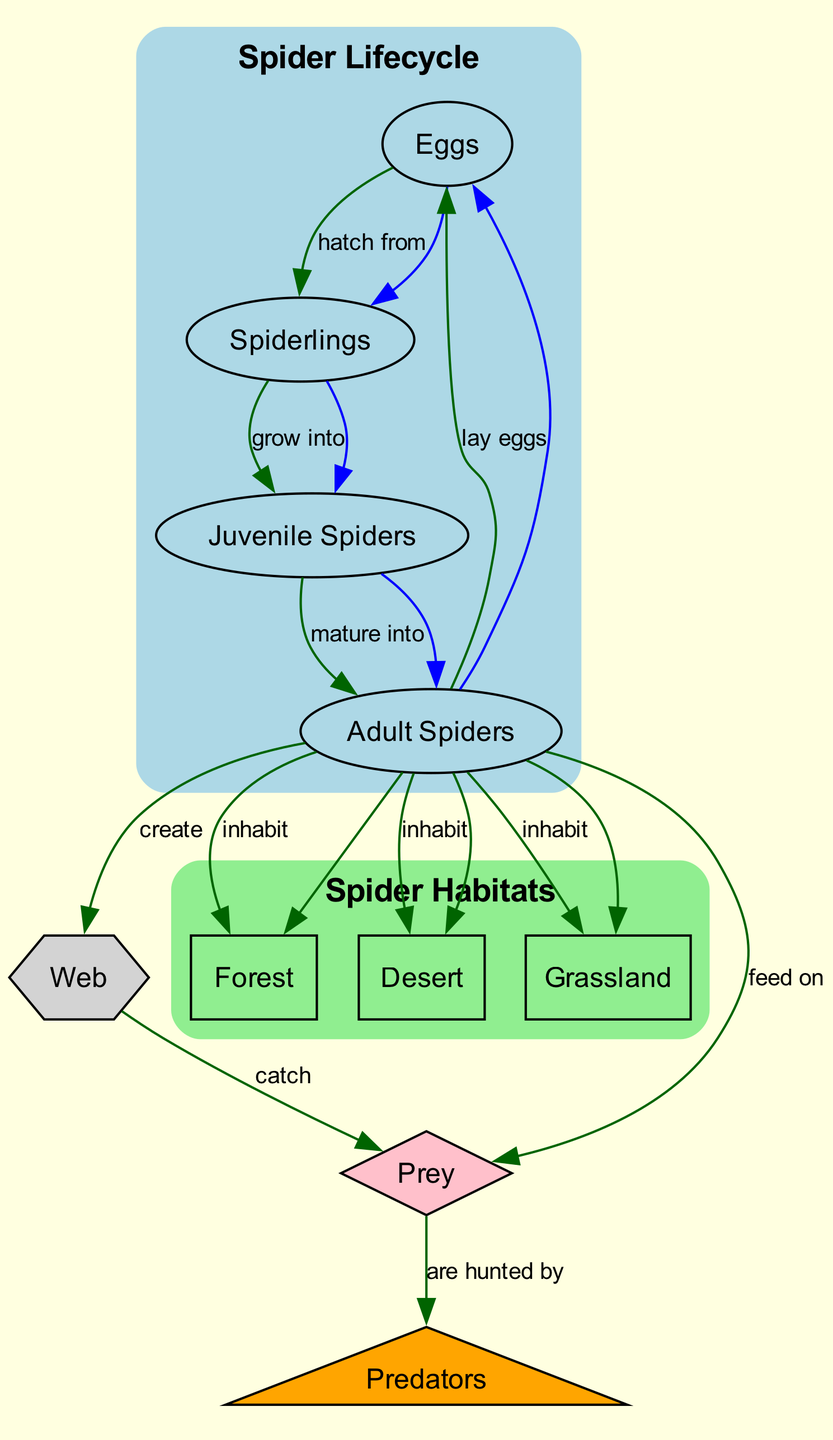What is the first stage in the spider lifecycle? The diagram starts by presenting "Eggs" as the first node in the spider lifecycle. This stage is indicated by the arrows leading from this node to the "Spiderlings" node, highlighting that the lifecycle begins with eggs being laid.
Answer: Eggs How many habitats are there where adult spiders inhabit? The diagram shows three edges leading from the "Adult Spiders" node to the habitat nodes: "Forest," "Desert," and "Grassland." By counting these connections, we find that there are three different habitats.
Answer: 3 What do adult spiders feed on? By following the edge from the "Adult Spiders" node to the "Prey" node, we can see that adult spiders have an arrow pointing to the prey, which indicates that they feed on insects and small animals.
Answer: Prey What stage comes after spiderlings? The flow from "Spiderlings" leads directly to the "Juvenile Spiders" node, indicating the development stage that follows spiderlings. Therefore, the answer is "Juvenile Spiders."
Answer: Juvenile Spiders Which habitat is primarily occupied by specially adapted spiders? The edges from the "Adult Spiders" node include a connection to "Desert," which is labeled as having specially adapted spiders. This information directly tells us which environment hosts these spiders.
Answer: Desert How do adult spiders catch their prey? The arrow from the "Web" node to the "Prey" node indicates that adult spiders create webs specifically to catch their prey. This relationship illustrates the role of webs in hunting.
Answer: Catch What do spiders create to assist in catching prey? The "Adult Spiders" node is linked to the "Web" node with an edge stating "create," indicating that adult spiders build webs as part of their hunting strategy.
Answer: Web Who hunts the prey of adult spiders? The diagram illustrates a relationship from the "Prey" node leading to the "Predators" node, identifying that the prey is hunted by various animals, which fulfills the question's criteria.
Answer: Predators 